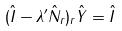Convert formula to latex. <formula><loc_0><loc_0><loc_500><loc_500>( \hat { I } - \lambda ^ { \prime } \hat { N } _ { r } ) _ { r } \hat { Y } = \hat { I }</formula> 